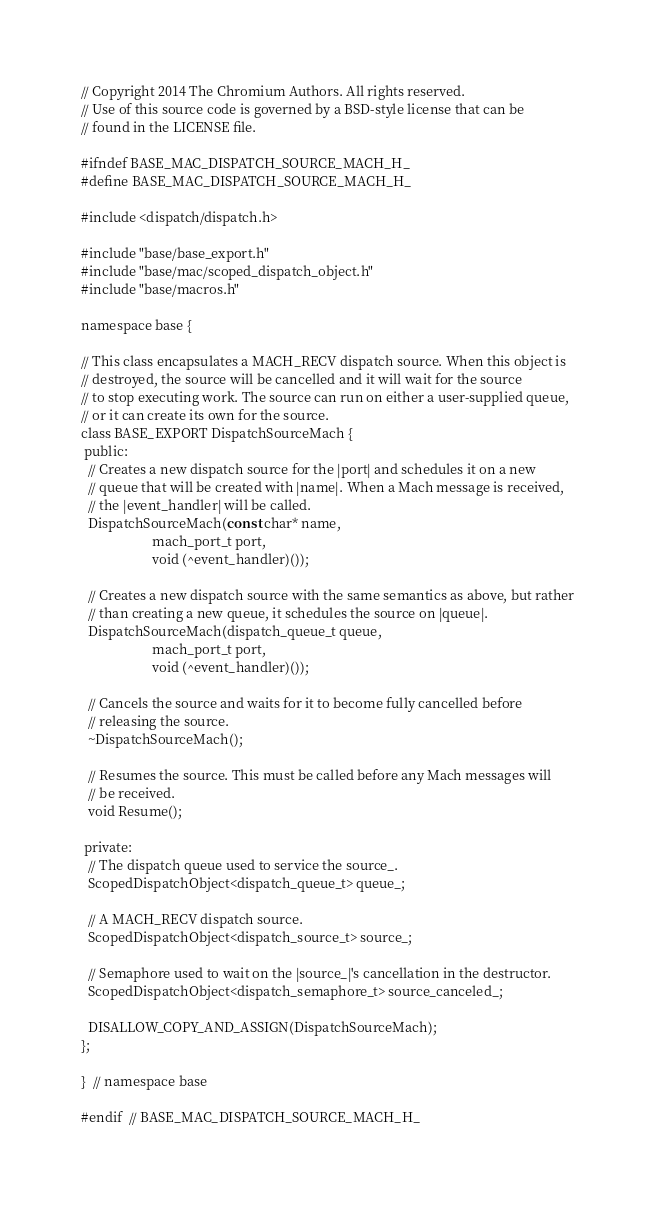Convert code to text. <code><loc_0><loc_0><loc_500><loc_500><_C_>// Copyright 2014 The Chromium Authors. All rights reserved.
// Use of this source code is governed by a BSD-style license that can be
// found in the LICENSE file.

#ifndef BASE_MAC_DISPATCH_SOURCE_MACH_H_
#define BASE_MAC_DISPATCH_SOURCE_MACH_H_

#include <dispatch/dispatch.h>

#include "base/base_export.h"
#include "base/mac/scoped_dispatch_object.h"
#include "base/macros.h"

namespace base {

// This class encapsulates a MACH_RECV dispatch source. When this object is
// destroyed, the source will be cancelled and it will wait for the source
// to stop executing work. The source can run on either a user-supplied queue,
// or it can create its own for the source.
class BASE_EXPORT DispatchSourceMach {
 public:
  // Creates a new dispatch source for the |port| and schedules it on a new
  // queue that will be created with |name|. When a Mach message is received,
  // the |event_handler| will be called.
  DispatchSourceMach(const char* name,
                     mach_port_t port,
                     void (^event_handler)());

  // Creates a new dispatch source with the same semantics as above, but rather
  // than creating a new queue, it schedules the source on |queue|.
  DispatchSourceMach(dispatch_queue_t queue,
                     mach_port_t port,
                     void (^event_handler)());

  // Cancels the source and waits for it to become fully cancelled before
  // releasing the source.
  ~DispatchSourceMach();

  // Resumes the source. This must be called before any Mach messages will
  // be received.
  void Resume();

 private:
  // The dispatch queue used to service the source_.
  ScopedDispatchObject<dispatch_queue_t> queue_;

  // A MACH_RECV dispatch source.
  ScopedDispatchObject<dispatch_source_t> source_;

  // Semaphore used to wait on the |source_|'s cancellation in the destructor.
  ScopedDispatchObject<dispatch_semaphore_t> source_canceled_;

  DISALLOW_COPY_AND_ASSIGN(DispatchSourceMach);
};

}  // namespace base

#endif  // BASE_MAC_DISPATCH_SOURCE_MACH_H_
</code> 